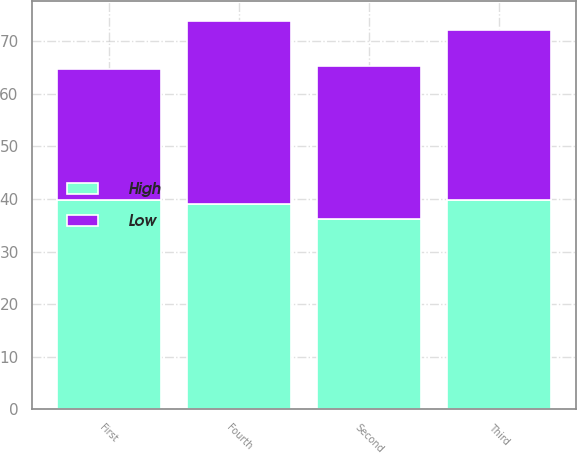<chart> <loc_0><loc_0><loc_500><loc_500><stacked_bar_chart><ecel><fcel>First<fcel>Second<fcel>Third<fcel>Fourth<nl><fcel>High<fcel>39.82<fcel>36.18<fcel>39.75<fcel>39<nl><fcel>Low<fcel>24.93<fcel>29.18<fcel>32.36<fcel>34.91<nl></chart> 